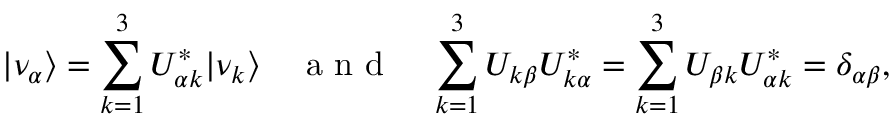Convert formula to latex. <formula><loc_0><loc_0><loc_500><loc_500>| \nu _ { \alpha } \rangle = \sum _ { k = 1 } ^ { 3 } U _ { \alpha k } ^ { \ast } | \nu _ { k } \rangle \quad a n d \quad \sum _ { k = 1 } ^ { 3 } U _ { k \beta } U _ { k \alpha } ^ { \ast } = \sum _ { k = 1 } ^ { 3 } U _ { \beta k } U _ { \alpha k } ^ { \ast } = \delta _ { \alpha \beta } ,</formula> 